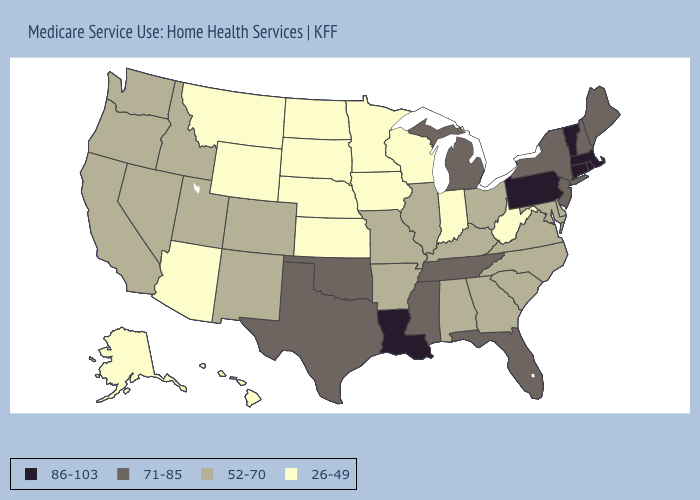Among the states that border Wyoming , does Montana have the lowest value?
Short answer required. Yes. Does Michigan have the highest value in the MidWest?
Short answer required. Yes. What is the value of Connecticut?
Be succinct. 86-103. Does Colorado have the same value as North Carolina?
Short answer required. Yes. Does New Mexico have the same value as Alabama?
Keep it brief. Yes. Which states have the lowest value in the West?
Give a very brief answer. Alaska, Arizona, Hawaii, Montana, Wyoming. How many symbols are there in the legend?
Give a very brief answer. 4. What is the value of Hawaii?
Keep it brief. 26-49. What is the lowest value in states that border Arkansas?
Give a very brief answer. 52-70. What is the lowest value in the USA?
Be succinct. 26-49. What is the highest value in the USA?
Concise answer only. 86-103. Name the states that have a value in the range 26-49?
Give a very brief answer. Alaska, Arizona, Hawaii, Indiana, Iowa, Kansas, Minnesota, Montana, Nebraska, North Dakota, South Dakota, West Virginia, Wisconsin, Wyoming. Name the states that have a value in the range 71-85?
Write a very short answer. Florida, Maine, Michigan, Mississippi, New Hampshire, New Jersey, New York, Oklahoma, Tennessee, Texas. Among the states that border Connecticut , does New York have the highest value?
Give a very brief answer. No. 